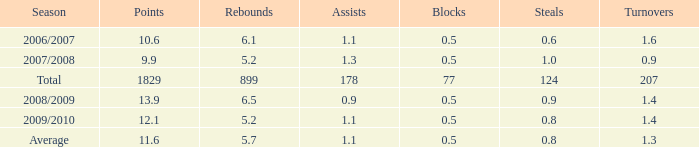What is the maximum rebounds when there are 0.9 steals and fewer than 1.4 turnovers? None. 